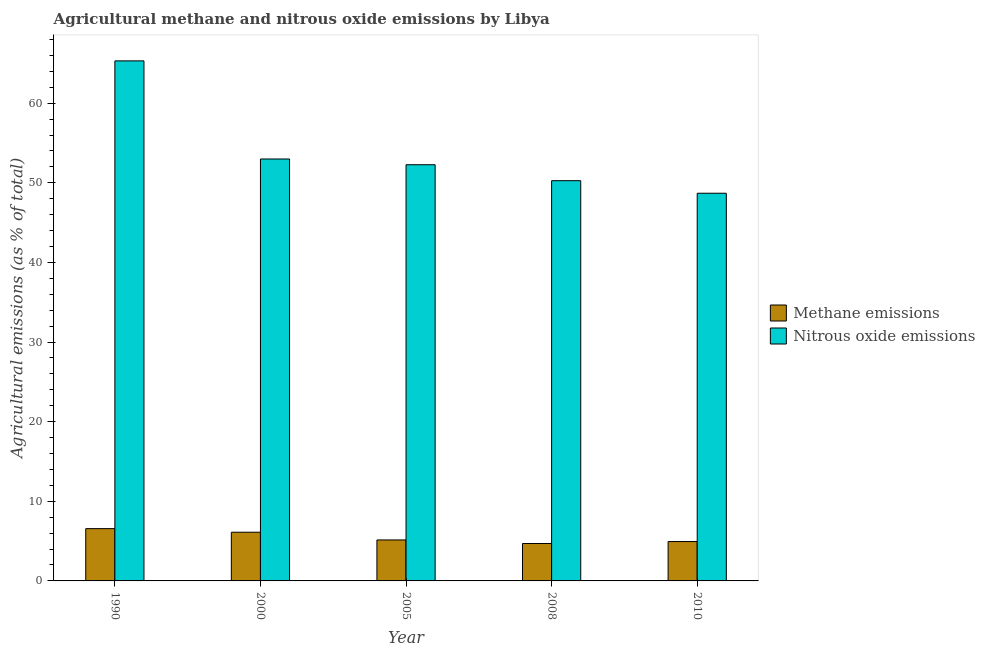Are the number of bars per tick equal to the number of legend labels?
Offer a very short reply. Yes. Are the number of bars on each tick of the X-axis equal?
Provide a succinct answer. Yes. How many bars are there on the 5th tick from the right?
Make the answer very short. 2. What is the label of the 5th group of bars from the left?
Your answer should be compact. 2010. What is the amount of nitrous oxide emissions in 2008?
Provide a succinct answer. 50.27. Across all years, what is the maximum amount of methane emissions?
Your answer should be very brief. 6.57. Across all years, what is the minimum amount of methane emissions?
Provide a short and direct response. 4.7. What is the total amount of nitrous oxide emissions in the graph?
Offer a terse response. 269.53. What is the difference between the amount of methane emissions in 2005 and that in 2010?
Give a very brief answer. 0.2. What is the difference between the amount of nitrous oxide emissions in 2005 and the amount of methane emissions in 2010?
Your response must be concise. 3.58. What is the average amount of methane emissions per year?
Your answer should be very brief. 5.5. What is the ratio of the amount of methane emissions in 2005 to that in 2010?
Your response must be concise. 1.04. Is the amount of methane emissions in 1990 less than that in 2010?
Make the answer very short. No. What is the difference between the highest and the second highest amount of nitrous oxide emissions?
Offer a very short reply. 12.32. What is the difference between the highest and the lowest amount of methane emissions?
Offer a terse response. 1.87. Is the sum of the amount of methane emissions in 2008 and 2010 greater than the maximum amount of nitrous oxide emissions across all years?
Make the answer very short. Yes. What does the 2nd bar from the left in 1990 represents?
Offer a very short reply. Nitrous oxide emissions. What does the 1st bar from the right in 2005 represents?
Your answer should be very brief. Nitrous oxide emissions. How many bars are there?
Provide a succinct answer. 10. Are all the bars in the graph horizontal?
Make the answer very short. No. How many years are there in the graph?
Your response must be concise. 5. Are the values on the major ticks of Y-axis written in scientific E-notation?
Your response must be concise. No. Does the graph contain grids?
Your response must be concise. No. How are the legend labels stacked?
Your answer should be very brief. Vertical. What is the title of the graph?
Keep it short and to the point. Agricultural methane and nitrous oxide emissions by Libya. What is the label or title of the Y-axis?
Provide a short and direct response. Agricultural emissions (as % of total). What is the Agricultural emissions (as % of total) of Methane emissions in 1990?
Keep it short and to the point. 6.57. What is the Agricultural emissions (as % of total) in Nitrous oxide emissions in 1990?
Provide a succinct answer. 65.31. What is the Agricultural emissions (as % of total) of Methane emissions in 2000?
Offer a terse response. 6.12. What is the Agricultural emissions (as % of total) in Nitrous oxide emissions in 2000?
Give a very brief answer. 52.99. What is the Agricultural emissions (as % of total) in Methane emissions in 2005?
Offer a terse response. 5.15. What is the Agricultural emissions (as % of total) in Nitrous oxide emissions in 2005?
Provide a short and direct response. 52.27. What is the Agricultural emissions (as % of total) of Methane emissions in 2008?
Give a very brief answer. 4.7. What is the Agricultural emissions (as % of total) in Nitrous oxide emissions in 2008?
Your response must be concise. 50.27. What is the Agricultural emissions (as % of total) of Methane emissions in 2010?
Make the answer very short. 4.95. What is the Agricultural emissions (as % of total) in Nitrous oxide emissions in 2010?
Make the answer very short. 48.69. Across all years, what is the maximum Agricultural emissions (as % of total) of Methane emissions?
Your response must be concise. 6.57. Across all years, what is the maximum Agricultural emissions (as % of total) in Nitrous oxide emissions?
Offer a terse response. 65.31. Across all years, what is the minimum Agricultural emissions (as % of total) of Methane emissions?
Offer a very short reply. 4.7. Across all years, what is the minimum Agricultural emissions (as % of total) of Nitrous oxide emissions?
Ensure brevity in your answer.  48.69. What is the total Agricultural emissions (as % of total) in Methane emissions in the graph?
Provide a short and direct response. 27.48. What is the total Agricultural emissions (as % of total) in Nitrous oxide emissions in the graph?
Make the answer very short. 269.53. What is the difference between the Agricultural emissions (as % of total) of Methane emissions in 1990 and that in 2000?
Provide a succinct answer. 0.45. What is the difference between the Agricultural emissions (as % of total) of Nitrous oxide emissions in 1990 and that in 2000?
Keep it short and to the point. 12.32. What is the difference between the Agricultural emissions (as % of total) of Methane emissions in 1990 and that in 2005?
Provide a short and direct response. 1.42. What is the difference between the Agricultural emissions (as % of total) of Nitrous oxide emissions in 1990 and that in 2005?
Offer a very short reply. 13.04. What is the difference between the Agricultural emissions (as % of total) of Methane emissions in 1990 and that in 2008?
Your response must be concise. 1.87. What is the difference between the Agricultural emissions (as % of total) of Nitrous oxide emissions in 1990 and that in 2008?
Give a very brief answer. 15.05. What is the difference between the Agricultural emissions (as % of total) of Methane emissions in 1990 and that in 2010?
Offer a very short reply. 1.62. What is the difference between the Agricultural emissions (as % of total) in Nitrous oxide emissions in 1990 and that in 2010?
Your answer should be very brief. 16.62. What is the difference between the Agricultural emissions (as % of total) of Methane emissions in 2000 and that in 2005?
Your answer should be compact. 0.97. What is the difference between the Agricultural emissions (as % of total) in Nitrous oxide emissions in 2000 and that in 2005?
Your response must be concise. 0.72. What is the difference between the Agricultural emissions (as % of total) of Methane emissions in 2000 and that in 2008?
Give a very brief answer. 1.42. What is the difference between the Agricultural emissions (as % of total) of Nitrous oxide emissions in 2000 and that in 2008?
Offer a terse response. 2.72. What is the difference between the Agricultural emissions (as % of total) of Methane emissions in 2000 and that in 2010?
Offer a very short reply. 1.17. What is the difference between the Agricultural emissions (as % of total) of Nitrous oxide emissions in 2000 and that in 2010?
Offer a very short reply. 4.3. What is the difference between the Agricultural emissions (as % of total) of Methane emissions in 2005 and that in 2008?
Ensure brevity in your answer.  0.45. What is the difference between the Agricultural emissions (as % of total) in Nitrous oxide emissions in 2005 and that in 2008?
Give a very brief answer. 2. What is the difference between the Agricultural emissions (as % of total) in Methane emissions in 2005 and that in 2010?
Provide a succinct answer. 0.2. What is the difference between the Agricultural emissions (as % of total) of Nitrous oxide emissions in 2005 and that in 2010?
Give a very brief answer. 3.58. What is the difference between the Agricultural emissions (as % of total) in Methane emissions in 2008 and that in 2010?
Make the answer very short. -0.25. What is the difference between the Agricultural emissions (as % of total) of Nitrous oxide emissions in 2008 and that in 2010?
Keep it short and to the point. 1.58. What is the difference between the Agricultural emissions (as % of total) in Methane emissions in 1990 and the Agricultural emissions (as % of total) in Nitrous oxide emissions in 2000?
Offer a terse response. -46.42. What is the difference between the Agricultural emissions (as % of total) in Methane emissions in 1990 and the Agricultural emissions (as % of total) in Nitrous oxide emissions in 2005?
Your answer should be very brief. -45.7. What is the difference between the Agricultural emissions (as % of total) in Methane emissions in 1990 and the Agricultural emissions (as % of total) in Nitrous oxide emissions in 2008?
Give a very brief answer. -43.7. What is the difference between the Agricultural emissions (as % of total) in Methane emissions in 1990 and the Agricultural emissions (as % of total) in Nitrous oxide emissions in 2010?
Ensure brevity in your answer.  -42.12. What is the difference between the Agricultural emissions (as % of total) of Methane emissions in 2000 and the Agricultural emissions (as % of total) of Nitrous oxide emissions in 2005?
Offer a very short reply. -46.15. What is the difference between the Agricultural emissions (as % of total) in Methane emissions in 2000 and the Agricultural emissions (as % of total) in Nitrous oxide emissions in 2008?
Provide a succinct answer. -44.15. What is the difference between the Agricultural emissions (as % of total) of Methane emissions in 2000 and the Agricultural emissions (as % of total) of Nitrous oxide emissions in 2010?
Provide a succinct answer. -42.57. What is the difference between the Agricultural emissions (as % of total) of Methane emissions in 2005 and the Agricultural emissions (as % of total) of Nitrous oxide emissions in 2008?
Keep it short and to the point. -45.12. What is the difference between the Agricultural emissions (as % of total) of Methane emissions in 2005 and the Agricultural emissions (as % of total) of Nitrous oxide emissions in 2010?
Offer a terse response. -43.54. What is the difference between the Agricultural emissions (as % of total) in Methane emissions in 2008 and the Agricultural emissions (as % of total) in Nitrous oxide emissions in 2010?
Offer a very short reply. -43.99. What is the average Agricultural emissions (as % of total) in Methane emissions per year?
Provide a succinct answer. 5.5. What is the average Agricultural emissions (as % of total) in Nitrous oxide emissions per year?
Offer a terse response. 53.91. In the year 1990, what is the difference between the Agricultural emissions (as % of total) in Methane emissions and Agricultural emissions (as % of total) in Nitrous oxide emissions?
Ensure brevity in your answer.  -58.74. In the year 2000, what is the difference between the Agricultural emissions (as % of total) in Methane emissions and Agricultural emissions (as % of total) in Nitrous oxide emissions?
Offer a very short reply. -46.87. In the year 2005, what is the difference between the Agricultural emissions (as % of total) of Methane emissions and Agricultural emissions (as % of total) of Nitrous oxide emissions?
Make the answer very short. -47.12. In the year 2008, what is the difference between the Agricultural emissions (as % of total) in Methane emissions and Agricultural emissions (as % of total) in Nitrous oxide emissions?
Your response must be concise. -45.57. In the year 2010, what is the difference between the Agricultural emissions (as % of total) in Methane emissions and Agricultural emissions (as % of total) in Nitrous oxide emissions?
Offer a very short reply. -43.74. What is the ratio of the Agricultural emissions (as % of total) in Methane emissions in 1990 to that in 2000?
Keep it short and to the point. 1.07. What is the ratio of the Agricultural emissions (as % of total) of Nitrous oxide emissions in 1990 to that in 2000?
Provide a succinct answer. 1.23. What is the ratio of the Agricultural emissions (as % of total) in Methane emissions in 1990 to that in 2005?
Your answer should be compact. 1.28. What is the ratio of the Agricultural emissions (as % of total) in Nitrous oxide emissions in 1990 to that in 2005?
Keep it short and to the point. 1.25. What is the ratio of the Agricultural emissions (as % of total) in Methane emissions in 1990 to that in 2008?
Make the answer very short. 1.4. What is the ratio of the Agricultural emissions (as % of total) in Nitrous oxide emissions in 1990 to that in 2008?
Give a very brief answer. 1.3. What is the ratio of the Agricultural emissions (as % of total) in Methane emissions in 1990 to that in 2010?
Keep it short and to the point. 1.33. What is the ratio of the Agricultural emissions (as % of total) of Nitrous oxide emissions in 1990 to that in 2010?
Provide a succinct answer. 1.34. What is the ratio of the Agricultural emissions (as % of total) of Methane emissions in 2000 to that in 2005?
Offer a very short reply. 1.19. What is the ratio of the Agricultural emissions (as % of total) of Nitrous oxide emissions in 2000 to that in 2005?
Provide a succinct answer. 1.01. What is the ratio of the Agricultural emissions (as % of total) in Methane emissions in 2000 to that in 2008?
Offer a terse response. 1.3. What is the ratio of the Agricultural emissions (as % of total) of Nitrous oxide emissions in 2000 to that in 2008?
Your answer should be very brief. 1.05. What is the ratio of the Agricultural emissions (as % of total) in Methane emissions in 2000 to that in 2010?
Make the answer very short. 1.24. What is the ratio of the Agricultural emissions (as % of total) of Nitrous oxide emissions in 2000 to that in 2010?
Provide a succinct answer. 1.09. What is the ratio of the Agricultural emissions (as % of total) of Methane emissions in 2005 to that in 2008?
Give a very brief answer. 1.1. What is the ratio of the Agricultural emissions (as % of total) of Nitrous oxide emissions in 2005 to that in 2008?
Your answer should be compact. 1.04. What is the ratio of the Agricultural emissions (as % of total) in Methane emissions in 2005 to that in 2010?
Give a very brief answer. 1.04. What is the ratio of the Agricultural emissions (as % of total) in Nitrous oxide emissions in 2005 to that in 2010?
Give a very brief answer. 1.07. What is the ratio of the Agricultural emissions (as % of total) in Methane emissions in 2008 to that in 2010?
Your response must be concise. 0.95. What is the ratio of the Agricultural emissions (as % of total) of Nitrous oxide emissions in 2008 to that in 2010?
Offer a terse response. 1.03. What is the difference between the highest and the second highest Agricultural emissions (as % of total) of Methane emissions?
Your response must be concise. 0.45. What is the difference between the highest and the second highest Agricultural emissions (as % of total) of Nitrous oxide emissions?
Give a very brief answer. 12.32. What is the difference between the highest and the lowest Agricultural emissions (as % of total) of Methane emissions?
Give a very brief answer. 1.87. What is the difference between the highest and the lowest Agricultural emissions (as % of total) of Nitrous oxide emissions?
Offer a very short reply. 16.62. 